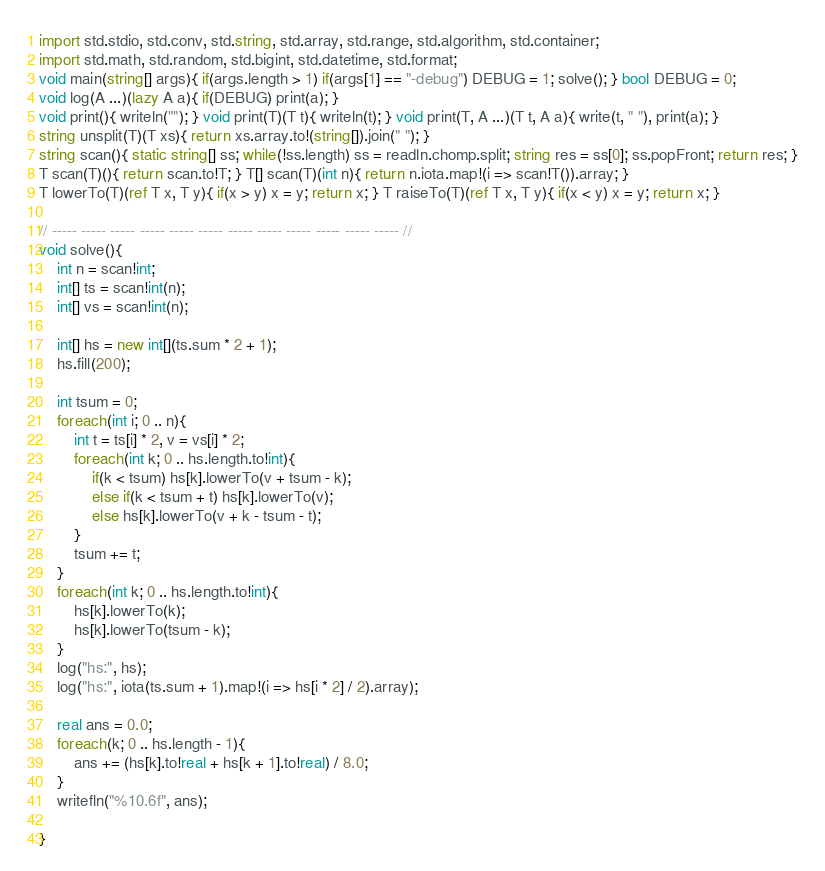<code> <loc_0><loc_0><loc_500><loc_500><_D_>import std.stdio, std.conv, std.string, std.array, std.range, std.algorithm, std.container;
import std.math, std.random, std.bigint, std.datetime, std.format;
void main(string[] args){ if(args.length > 1) if(args[1] == "-debug") DEBUG = 1; solve(); } bool DEBUG = 0;
void log(A ...)(lazy A a){ if(DEBUG) print(a); }
void print(){ writeln(""); } void print(T)(T t){ writeln(t); } void print(T, A ...)(T t, A a){ write(t, " "), print(a); }
string unsplit(T)(T xs){ return xs.array.to!(string[]).join(" "); }
string scan(){ static string[] ss; while(!ss.length) ss = readln.chomp.split; string res = ss[0]; ss.popFront; return res; }
T scan(T)(){ return scan.to!T; } T[] scan(T)(int n){ return n.iota.map!(i => scan!T()).array; }
T lowerTo(T)(ref T x, T y){ if(x > y) x = y; return x; } T raiseTo(T)(ref T x, T y){ if(x < y) x = y; return x; }

// ----- ----- ----- ----- ----- ----- ----- ----- ----- ----- ----- ----- //
void solve(){
    int n = scan!int;
    int[] ts = scan!int(n);
    int[] vs = scan!int(n);

    int[] hs = new int[](ts.sum * 2 + 1);
    hs.fill(200);

    int tsum = 0;
    foreach(int i; 0 .. n){
        int t = ts[i] * 2, v = vs[i] * 2;
        foreach(int k; 0 .. hs.length.to!int){
            if(k < tsum) hs[k].lowerTo(v + tsum - k);
            else if(k < tsum + t) hs[k].lowerTo(v);
            else hs[k].lowerTo(v + k - tsum - t);
        }
        tsum += t;
    }
    foreach(int k; 0 .. hs.length.to!int){
        hs[k].lowerTo(k);
        hs[k].lowerTo(tsum - k);
    }
    log("hs:", hs);
    log("hs:", iota(ts.sum + 1).map!(i => hs[i * 2] / 2).array);

    real ans = 0.0;
    foreach(k; 0 .. hs.length - 1){
        ans += (hs[k].to!real + hs[k + 1].to!real) / 8.0;
    }
    writefln("%10.6f", ans);

}</code> 